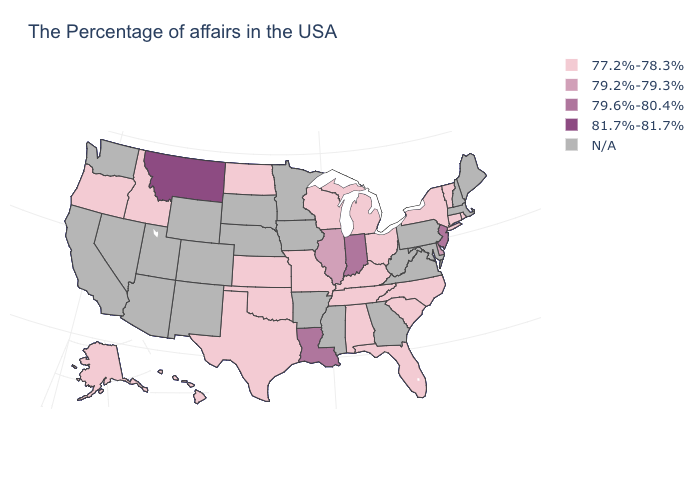Name the states that have a value in the range 79.6%-80.4%?
Short answer required. New Jersey, Indiana, Louisiana. What is the value of New Hampshire?
Give a very brief answer. N/A. What is the value of South Dakota?
Write a very short answer. N/A. What is the highest value in states that border North Carolina?
Give a very brief answer. 77.2%-78.3%. Among the states that border South Carolina , which have the highest value?
Concise answer only. North Carolina. Does the map have missing data?
Concise answer only. Yes. Does Indiana have the highest value in the MidWest?
Concise answer only. Yes. What is the value of Ohio?
Give a very brief answer. 77.2%-78.3%. What is the highest value in the USA?
Concise answer only. 81.7%-81.7%. What is the value of Missouri?
Write a very short answer. 77.2%-78.3%. What is the value of South Carolina?
Quick response, please. 77.2%-78.3%. How many symbols are there in the legend?
Short answer required. 5. Which states have the highest value in the USA?
Concise answer only. Montana. Does New York have the highest value in the USA?
Short answer required. No. 